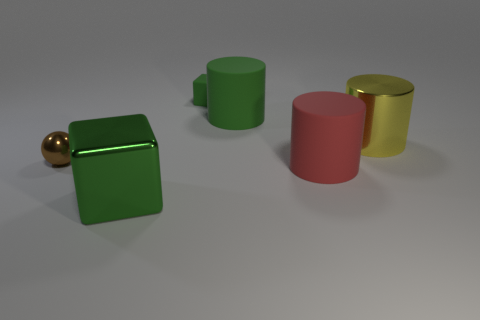Subtract all cyan balls. Subtract all cyan cylinders. How many balls are left? 1 Add 4 tiny red rubber cylinders. How many objects exist? 10 Subtract all spheres. How many objects are left? 5 Add 3 big yellow cylinders. How many big yellow cylinders exist? 4 Subtract 2 green cubes. How many objects are left? 4 Subtract all large green rubber cubes. Subtract all brown balls. How many objects are left? 5 Add 5 big shiny things. How many big shiny things are left? 7 